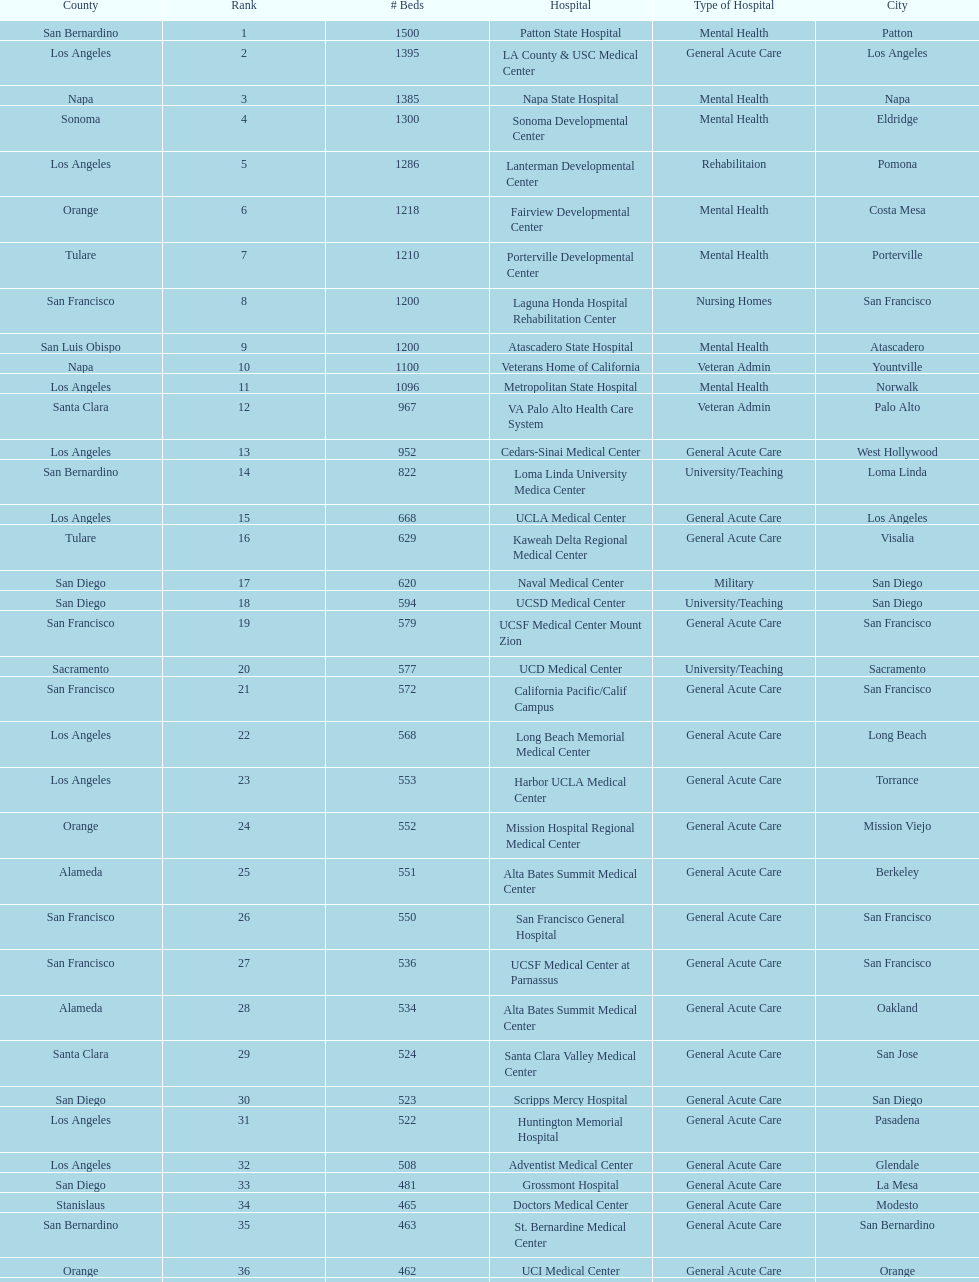Which type of hospitals are the same as grossmont hospital? General Acute Care. 